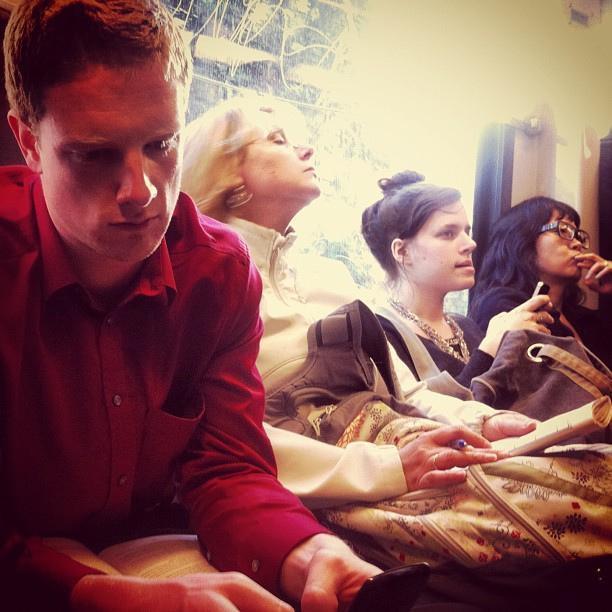How many people can you see?
Give a very brief answer. 4. How many handbags can you see?
Give a very brief answer. 3. 